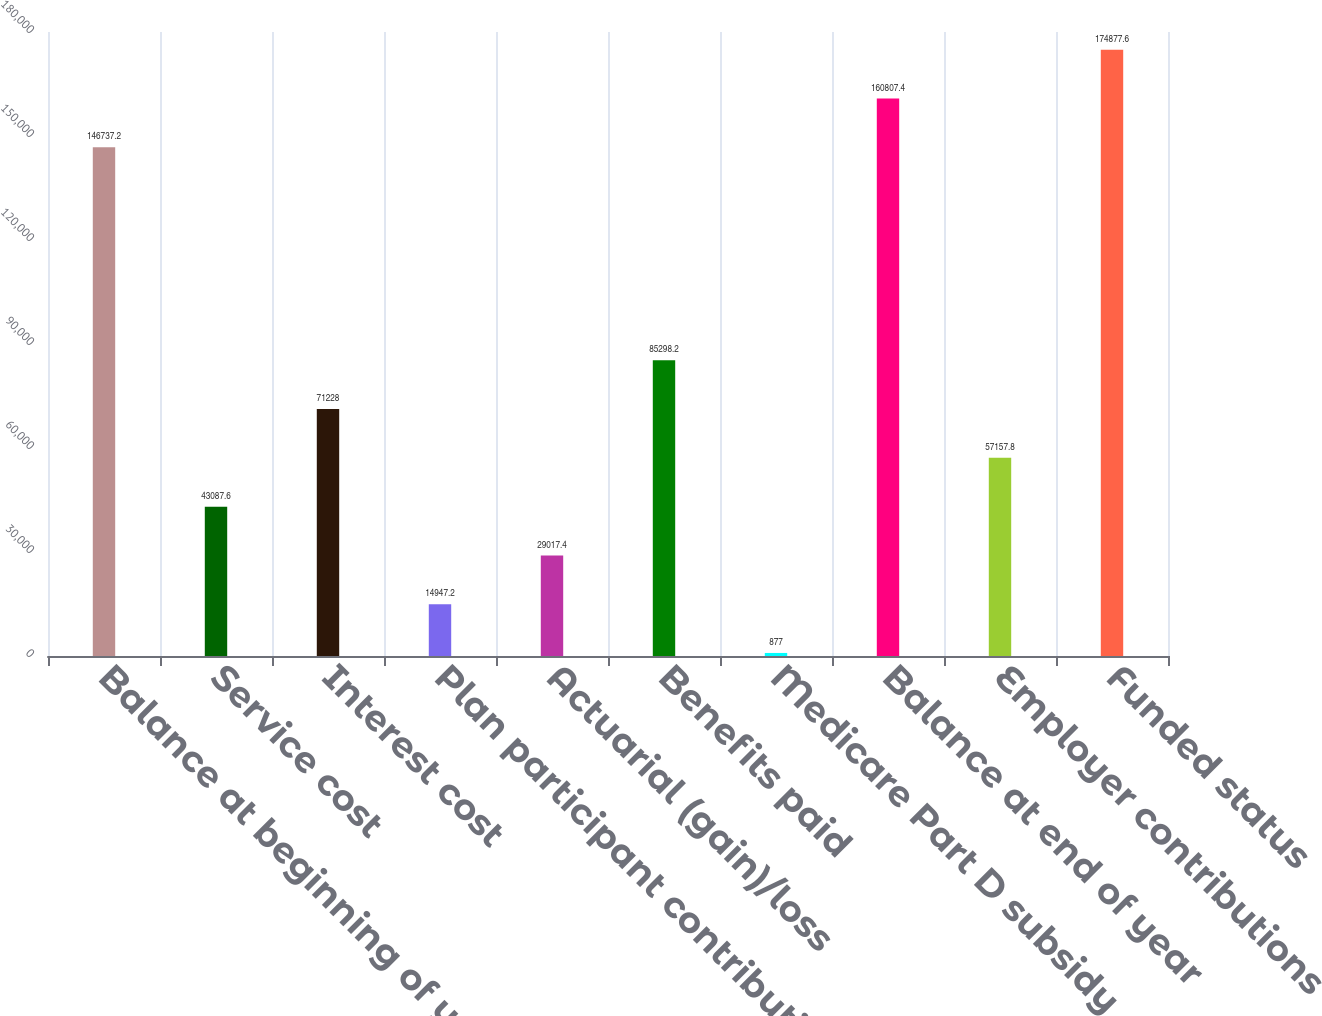Convert chart to OTSL. <chart><loc_0><loc_0><loc_500><loc_500><bar_chart><fcel>Balance at beginning of year<fcel>Service cost<fcel>Interest cost<fcel>Plan participant contributions<fcel>Actuarial (gain)/loss<fcel>Benefits paid<fcel>Medicare Part D subsidy<fcel>Balance at end of year<fcel>Employer contributions<fcel>Funded status<nl><fcel>146737<fcel>43087.6<fcel>71228<fcel>14947.2<fcel>29017.4<fcel>85298.2<fcel>877<fcel>160807<fcel>57157.8<fcel>174878<nl></chart> 